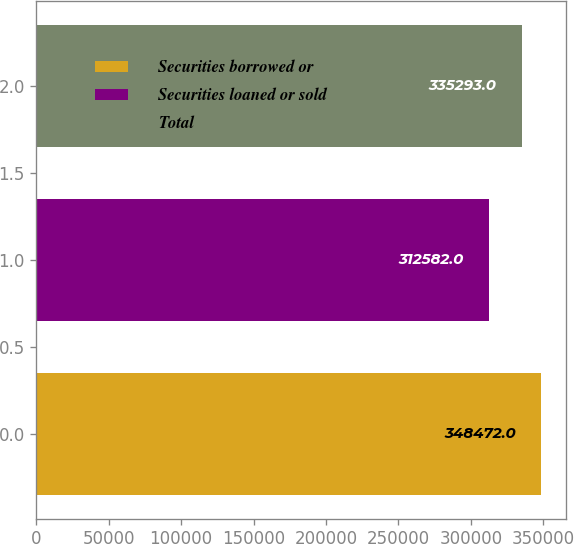<chart> <loc_0><loc_0><loc_500><loc_500><bar_chart><fcel>Securities borrowed or<fcel>Securities loaned or sold<fcel>Total<nl><fcel>348472<fcel>312582<fcel>335293<nl></chart> 